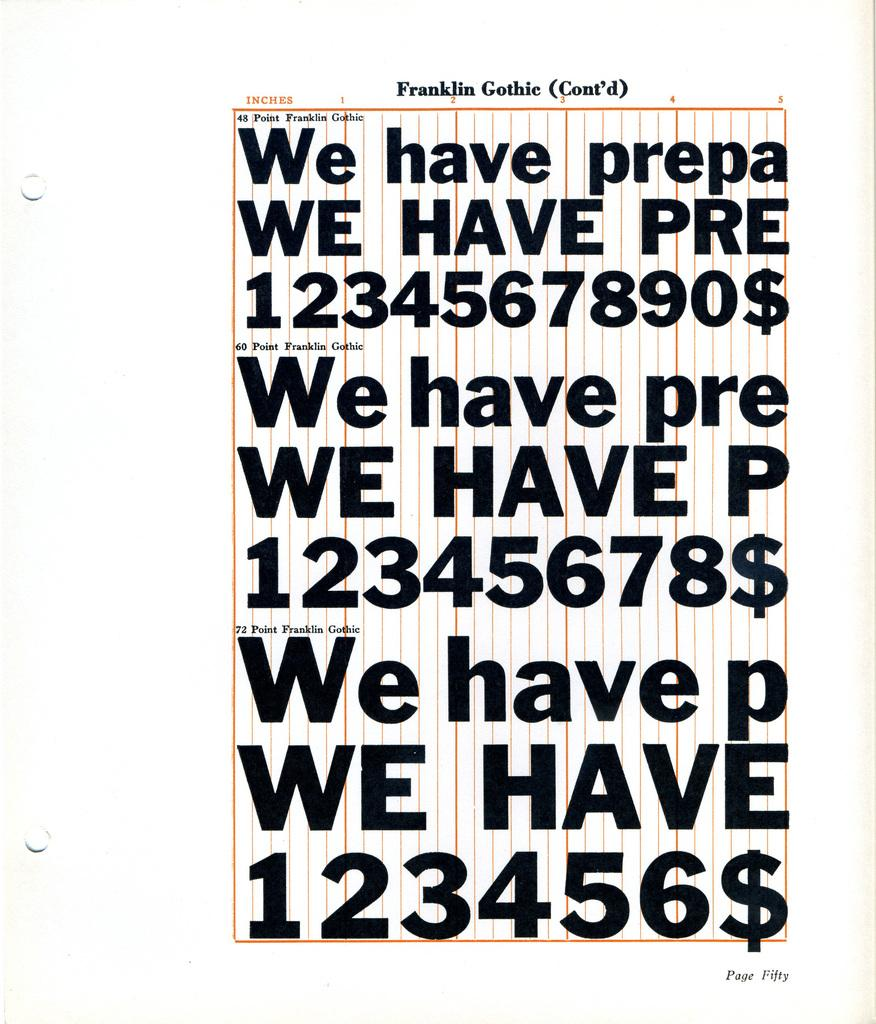<image>
Share a concise interpretation of the image provided. Page with fonts by Franklin Gothic showing letters and numbers. 